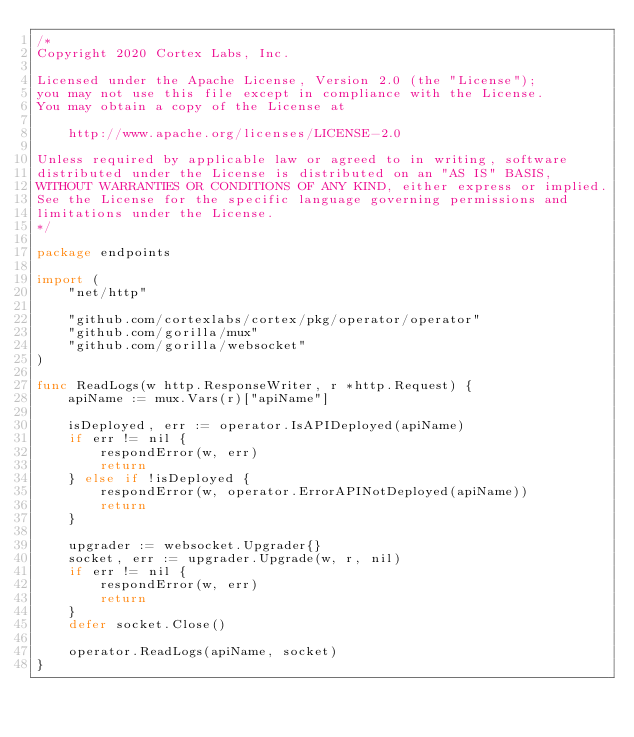<code> <loc_0><loc_0><loc_500><loc_500><_Go_>/*
Copyright 2020 Cortex Labs, Inc.

Licensed under the Apache License, Version 2.0 (the "License");
you may not use this file except in compliance with the License.
You may obtain a copy of the License at

    http://www.apache.org/licenses/LICENSE-2.0

Unless required by applicable law or agreed to in writing, software
distributed under the License is distributed on an "AS IS" BASIS,
WITHOUT WARRANTIES OR CONDITIONS OF ANY KIND, either express or implied.
See the License for the specific language governing permissions and
limitations under the License.
*/

package endpoints

import (
	"net/http"

	"github.com/cortexlabs/cortex/pkg/operator/operator"
	"github.com/gorilla/mux"
	"github.com/gorilla/websocket"
)

func ReadLogs(w http.ResponseWriter, r *http.Request) {
	apiName := mux.Vars(r)["apiName"]

	isDeployed, err := operator.IsAPIDeployed(apiName)
	if err != nil {
		respondError(w, err)
		return
	} else if !isDeployed {
		respondError(w, operator.ErrorAPINotDeployed(apiName))
		return
	}

	upgrader := websocket.Upgrader{}
	socket, err := upgrader.Upgrade(w, r, nil)
	if err != nil {
		respondError(w, err)
		return
	}
	defer socket.Close()

	operator.ReadLogs(apiName, socket)
}
</code> 